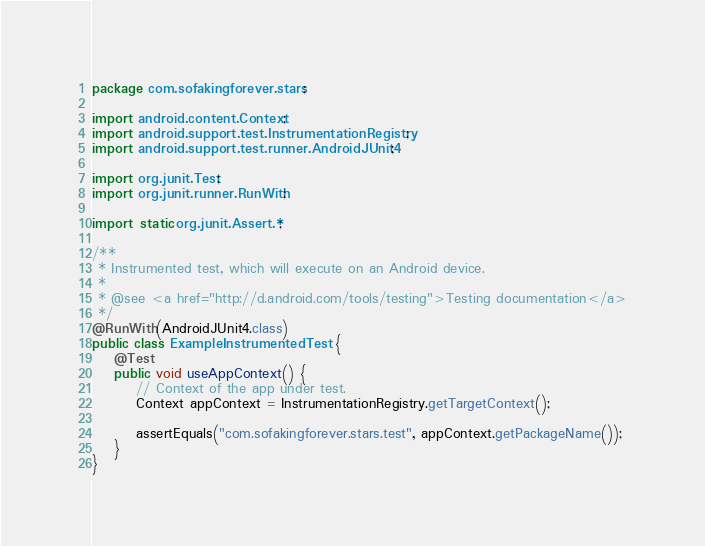Convert code to text. <code><loc_0><loc_0><loc_500><loc_500><_Java_>package com.sofakingforever.stars;

import android.content.Context;
import android.support.test.InstrumentationRegistry;
import android.support.test.runner.AndroidJUnit4;

import org.junit.Test;
import org.junit.runner.RunWith;

import static org.junit.Assert.*;

/**
 * Instrumented test, which will execute on an Android device.
 *
 * @see <a href="http://d.android.com/tools/testing">Testing documentation</a>
 */
@RunWith(AndroidJUnit4.class)
public class ExampleInstrumentedTest {
    @Test
    public void useAppContext() {
        // Context of the app under test.
        Context appContext = InstrumentationRegistry.getTargetContext();

        assertEquals("com.sofakingforever.stars.test", appContext.getPackageName());
    }
}
</code> 